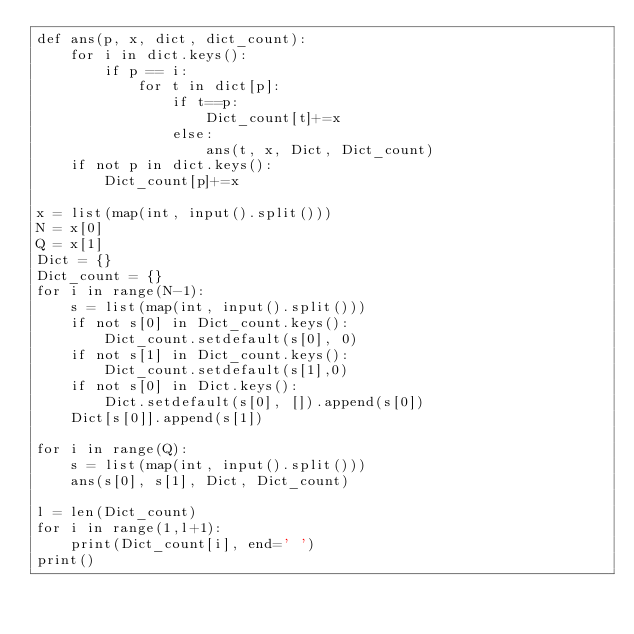<code> <loc_0><loc_0><loc_500><loc_500><_Python_>def ans(p, x, dict, dict_count):
    for i in dict.keys():
        if p == i:
            for t in dict[p]:
                if t==p:
                    Dict_count[t]+=x
                else:
                    ans(t, x, Dict, Dict_count)
    if not p in dict.keys():
        Dict_count[p]+=x 

x = list(map(int, input().split()))
N = x[0]
Q = x[1]
Dict = {}
Dict_count = {}
for i in range(N-1):
    s = list(map(int, input().split()))
    if not s[0] in Dict_count.keys():
        Dict_count.setdefault(s[0], 0)
    if not s[1] in Dict_count.keys():
        Dict_count.setdefault(s[1],0)
    if not s[0] in Dict.keys():
        Dict.setdefault(s[0], []).append(s[0])
    Dict[s[0]].append(s[1])

for i in range(Q):
    s = list(map(int, input().split()))
    ans(s[0], s[1], Dict, Dict_count)

l = len(Dict_count)
for i in range(1,l+1):
    print(Dict_count[i], end=' ')
print()</code> 